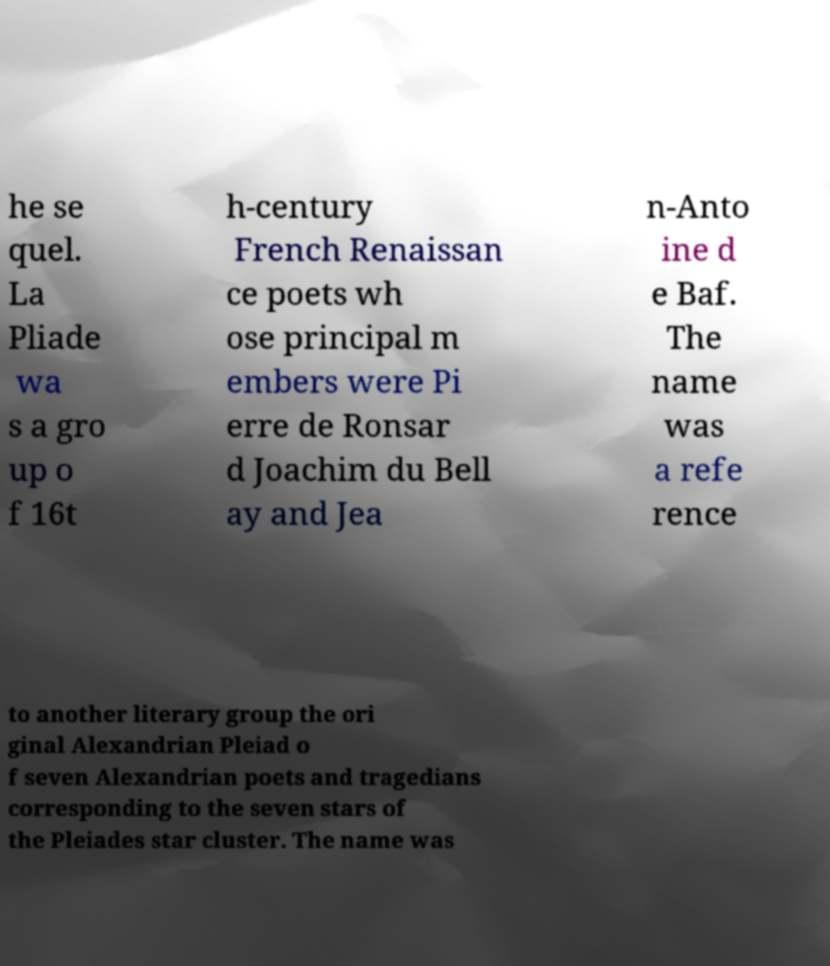Can you accurately transcribe the text from the provided image for me? he se quel. La Pliade wa s a gro up o f 16t h-century French Renaissan ce poets wh ose principal m embers were Pi erre de Ronsar d Joachim du Bell ay and Jea n-Anto ine d e Baf. The name was a refe rence to another literary group the ori ginal Alexandrian Pleiad o f seven Alexandrian poets and tragedians corresponding to the seven stars of the Pleiades star cluster. The name was 